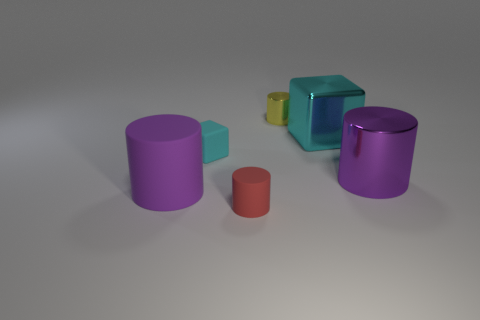Add 3 yellow cylinders. How many objects exist? 9 Subtract all cylinders. How many objects are left? 2 Subtract all big cyan metal cubes. Subtract all rubber cylinders. How many objects are left? 3 Add 1 tiny matte objects. How many tiny matte objects are left? 3 Add 3 matte things. How many matte things exist? 6 Subtract 0 cyan spheres. How many objects are left? 6 